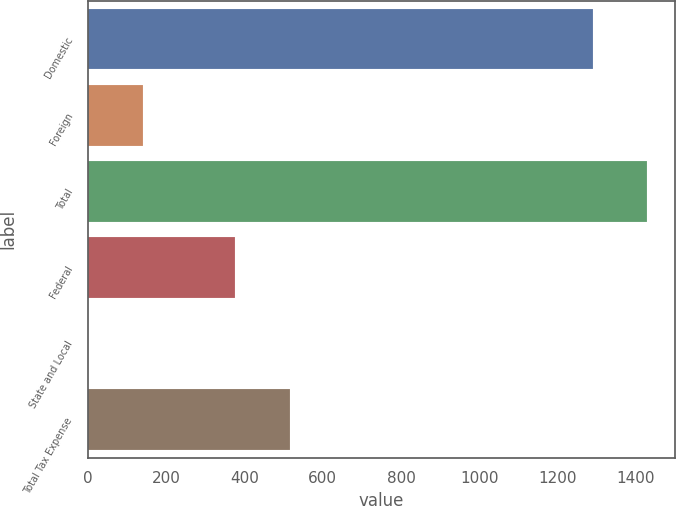Convert chart to OTSL. <chart><loc_0><loc_0><loc_500><loc_500><bar_chart><fcel>Domestic<fcel>Foreign<fcel>Total<fcel>Federal<fcel>State and Local<fcel>Total Tax Expense<nl><fcel>1289<fcel>140.76<fcel>1429.36<fcel>374.9<fcel>0.4<fcel>515.26<nl></chart> 